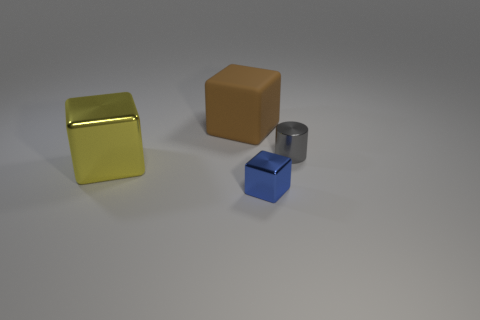Add 3 big brown metallic objects. How many objects exist? 7 Subtract all cylinders. How many objects are left? 3 Subtract all tiny balls. Subtract all tiny blue blocks. How many objects are left? 3 Add 4 big yellow blocks. How many big yellow blocks are left? 5 Add 1 tiny yellow shiny blocks. How many tiny yellow shiny blocks exist? 1 Subtract 0 purple cylinders. How many objects are left? 4 